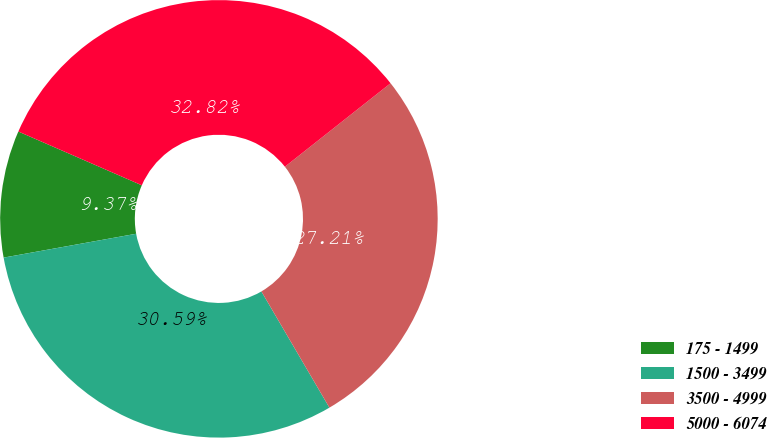Convert chart. <chart><loc_0><loc_0><loc_500><loc_500><pie_chart><fcel>175 - 1499<fcel>1500 - 3499<fcel>3500 - 4999<fcel>5000 - 6074<nl><fcel>9.37%<fcel>30.59%<fcel>27.21%<fcel>32.82%<nl></chart> 